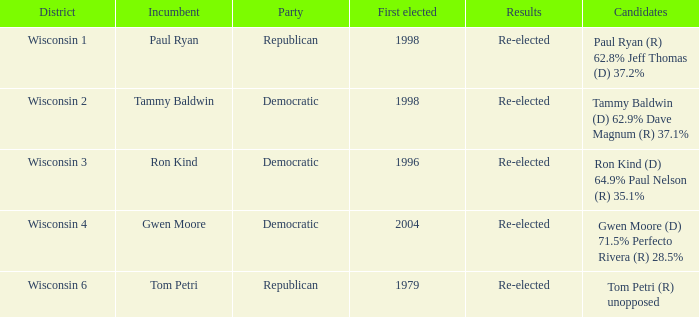In which district was a democratic incumbent first elected in 1998? Wisconsin 2. 